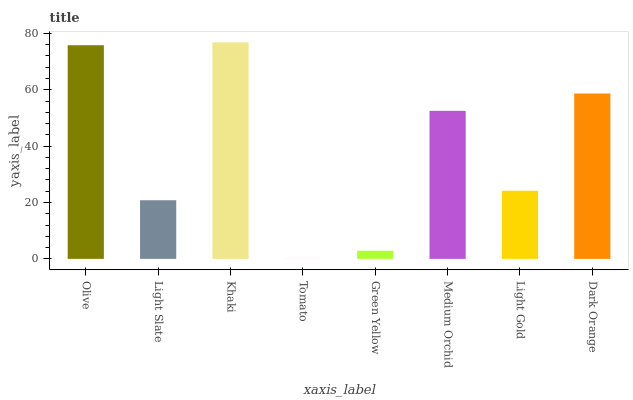Is Tomato the minimum?
Answer yes or no. Yes. Is Khaki the maximum?
Answer yes or no. Yes. Is Light Slate the minimum?
Answer yes or no. No. Is Light Slate the maximum?
Answer yes or no. No. Is Olive greater than Light Slate?
Answer yes or no. Yes. Is Light Slate less than Olive?
Answer yes or no. Yes. Is Light Slate greater than Olive?
Answer yes or no. No. Is Olive less than Light Slate?
Answer yes or no. No. Is Medium Orchid the high median?
Answer yes or no. Yes. Is Light Gold the low median?
Answer yes or no. Yes. Is Green Yellow the high median?
Answer yes or no. No. Is Medium Orchid the low median?
Answer yes or no. No. 